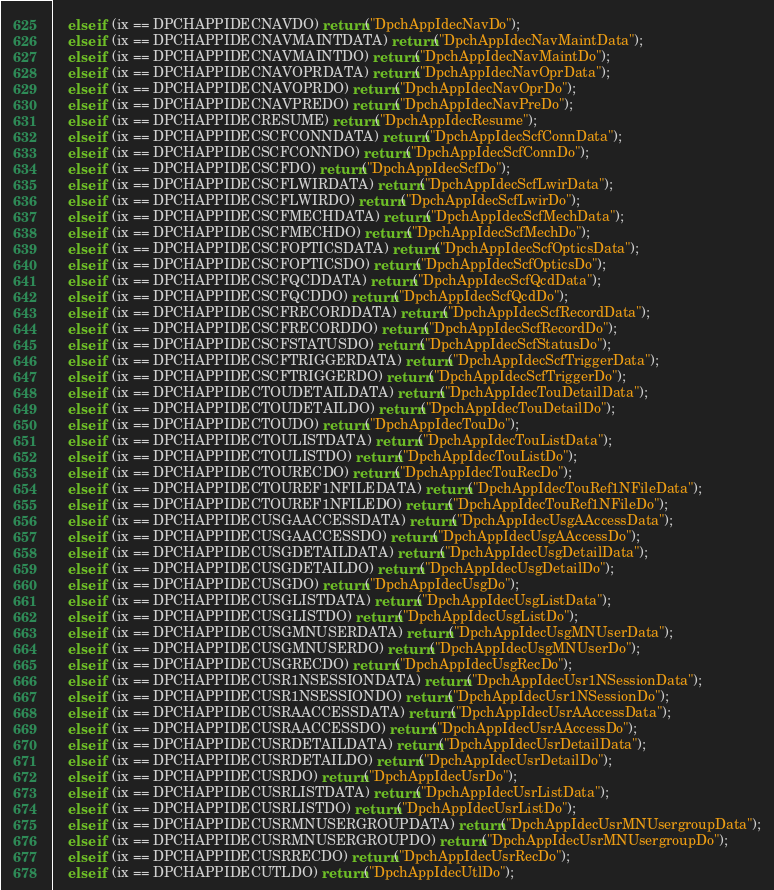Convert code to text. <code><loc_0><loc_0><loc_500><loc_500><_C++_>	else if (ix == DPCHAPPIDECNAVDO) return("DpchAppIdecNavDo");
	else if (ix == DPCHAPPIDECNAVMAINTDATA) return("DpchAppIdecNavMaintData");
	else if (ix == DPCHAPPIDECNAVMAINTDO) return("DpchAppIdecNavMaintDo");
	else if (ix == DPCHAPPIDECNAVOPRDATA) return("DpchAppIdecNavOprData");
	else if (ix == DPCHAPPIDECNAVOPRDO) return("DpchAppIdecNavOprDo");
	else if (ix == DPCHAPPIDECNAVPREDO) return("DpchAppIdecNavPreDo");
	else if (ix == DPCHAPPIDECRESUME) return("DpchAppIdecResume");
	else if (ix == DPCHAPPIDECSCFCONNDATA) return("DpchAppIdecScfConnData");
	else if (ix == DPCHAPPIDECSCFCONNDO) return("DpchAppIdecScfConnDo");
	else if (ix == DPCHAPPIDECSCFDO) return("DpchAppIdecScfDo");
	else if (ix == DPCHAPPIDECSCFLWIRDATA) return("DpchAppIdecScfLwirData");
	else if (ix == DPCHAPPIDECSCFLWIRDO) return("DpchAppIdecScfLwirDo");
	else if (ix == DPCHAPPIDECSCFMECHDATA) return("DpchAppIdecScfMechData");
	else if (ix == DPCHAPPIDECSCFMECHDO) return("DpchAppIdecScfMechDo");
	else if (ix == DPCHAPPIDECSCFOPTICSDATA) return("DpchAppIdecScfOpticsData");
	else if (ix == DPCHAPPIDECSCFOPTICSDO) return("DpchAppIdecScfOpticsDo");
	else if (ix == DPCHAPPIDECSCFQCDDATA) return("DpchAppIdecScfQcdData");
	else if (ix == DPCHAPPIDECSCFQCDDO) return("DpchAppIdecScfQcdDo");
	else if (ix == DPCHAPPIDECSCFRECORDDATA) return("DpchAppIdecScfRecordData");
	else if (ix == DPCHAPPIDECSCFRECORDDO) return("DpchAppIdecScfRecordDo");
	else if (ix == DPCHAPPIDECSCFSTATUSDO) return("DpchAppIdecScfStatusDo");
	else if (ix == DPCHAPPIDECSCFTRIGGERDATA) return("DpchAppIdecScfTriggerData");
	else if (ix == DPCHAPPIDECSCFTRIGGERDO) return("DpchAppIdecScfTriggerDo");
	else if (ix == DPCHAPPIDECTOUDETAILDATA) return("DpchAppIdecTouDetailData");
	else if (ix == DPCHAPPIDECTOUDETAILDO) return("DpchAppIdecTouDetailDo");
	else if (ix == DPCHAPPIDECTOUDO) return("DpchAppIdecTouDo");
	else if (ix == DPCHAPPIDECTOULISTDATA) return("DpchAppIdecTouListData");
	else if (ix == DPCHAPPIDECTOULISTDO) return("DpchAppIdecTouListDo");
	else if (ix == DPCHAPPIDECTOURECDO) return("DpchAppIdecTouRecDo");
	else if (ix == DPCHAPPIDECTOUREF1NFILEDATA) return("DpchAppIdecTouRef1NFileData");
	else if (ix == DPCHAPPIDECTOUREF1NFILEDO) return("DpchAppIdecTouRef1NFileDo");
	else if (ix == DPCHAPPIDECUSGAACCESSDATA) return("DpchAppIdecUsgAAccessData");
	else if (ix == DPCHAPPIDECUSGAACCESSDO) return("DpchAppIdecUsgAAccessDo");
	else if (ix == DPCHAPPIDECUSGDETAILDATA) return("DpchAppIdecUsgDetailData");
	else if (ix == DPCHAPPIDECUSGDETAILDO) return("DpchAppIdecUsgDetailDo");
	else if (ix == DPCHAPPIDECUSGDO) return("DpchAppIdecUsgDo");
	else if (ix == DPCHAPPIDECUSGLISTDATA) return("DpchAppIdecUsgListData");
	else if (ix == DPCHAPPIDECUSGLISTDO) return("DpchAppIdecUsgListDo");
	else if (ix == DPCHAPPIDECUSGMNUSERDATA) return("DpchAppIdecUsgMNUserData");
	else if (ix == DPCHAPPIDECUSGMNUSERDO) return("DpchAppIdecUsgMNUserDo");
	else if (ix == DPCHAPPIDECUSGRECDO) return("DpchAppIdecUsgRecDo");
	else if (ix == DPCHAPPIDECUSR1NSESSIONDATA) return("DpchAppIdecUsr1NSessionData");
	else if (ix == DPCHAPPIDECUSR1NSESSIONDO) return("DpchAppIdecUsr1NSessionDo");
	else if (ix == DPCHAPPIDECUSRAACCESSDATA) return("DpchAppIdecUsrAAccessData");
	else if (ix == DPCHAPPIDECUSRAACCESSDO) return("DpchAppIdecUsrAAccessDo");
	else if (ix == DPCHAPPIDECUSRDETAILDATA) return("DpchAppIdecUsrDetailData");
	else if (ix == DPCHAPPIDECUSRDETAILDO) return("DpchAppIdecUsrDetailDo");
	else if (ix == DPCHAPPIDECUSRDO) return("DpchAppIdecUsrDo");
	else if (ix == DPCHAPPIDECUSRLISTDATA) return("DpchAppIdecUsrListData");
	else if (ix == DPCHAPPIDECUSRLISTDO) return("DpchAppIdecUsrListDo");
	else if (ix == DPCHAPPIDECUSRMNUSERGROUPDATA) return("DpchAppIdecUsrMNUsergroupData");
	else if (ix == DPCHAPPIDECUSRMNUSERGROUPDO) return("DpchAppIdecUsrMNUsergroupDo");
	else if (ix == DPCHAPPIDECUSRRECDO) return("DpchAppIdecUsrRecDo");
	else if (ix == DPCHAPPIDECUTLDO) return("DpchAppIdecUtlDo");</code> 